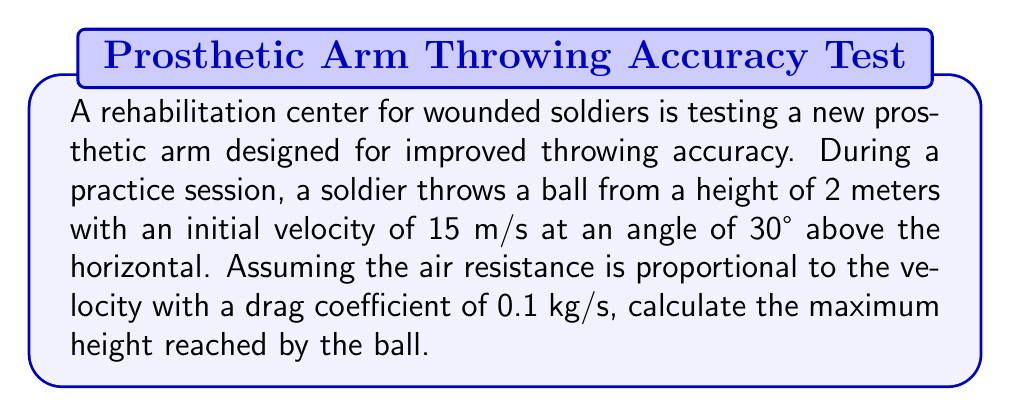Solve this math problem. To solve this problem, we need to consider the equations of motion with air resistance. Let's approach this step-by-step:

1) The equations of motion with air resistance are:

   $$\frac{dx}{dt} = v_x$$
   $$\frac{dy}{dt} = v_y$$
   $$\frac{dv_x}{dt} = -\frac{k}{m}v_x$$
   $$\frac{dv_y}{dt} = -g - \frac{k}{m}v_y$$

   Where $k$ is the drag coefficient, $m$ is the mass of the ball, and $g$ is the acceleration due to gravity.

2) The initial conditions are:
   $$x_0 = 0, y_0 = 2$$
   $$v_{x0} = v_0 \cos{\theta} = 15 \cos{30°} = 12.99 \text{ m/s}$$
   $$v_{y0} = v_0 \sin{\theta} = 15 \sin{30°} = 7.5 \text{ m/s}$$

3) To find the maximum height, we need to find when $v_y = 0$. The solution for $v_y$ is:

   $$v_y = \frac{mg}{k}(e^{-\frac{k}{m}t} - 1) + v_{y0}e^{-\frac{k}{m}t}$$

4) Setting this equal to zero and solving for $t$ gives:

   $$t = \frac{m}{k} \ln{\left(\frac{v_{y0} + \frac{mg}{k}}{\frac{mg}{k}}\right)}$$

5) Substituting this time into the equation for y:

   $$y = \frac{m}{k}\left(v_{y0} + \frac{mg}{k}\right)\left(1 - e^{-\frac{k}{m}t}\right) - \frac{mg}{k}t + y_0$$

6) Assuming the mass of the ball is 0.1 kg, and using g = 9.8 m/s^2:

   $$t = \frac{0.1}{0.1} \ln{\left(\frac{7.5 + \frac{0.1 \cdot 9.8}{0.1}}{\frac{0.1 \cdot 9.8}{0.1}}\right)} = 0.65 \text{ s}$$

7) Substituting this back into the equation for y:

   $$y_{max} = \frac{0.1}{0.1}\left(7.5 + \frac{0.1 \cdot 9.8}{0.1}\right)\left(1 - e^{-\frac{0.1}{0.1} \cdot 0.65}\right) - \frac{0.1 \cdot 9.8}{0.1} \cdot 0.65 + 2$$

8) Calculating this gives:

   $$y_{max} = 4.79 \text{ m}$$

Therefore, the maximum height reached by the ball is approximately 4.79 meters.
Answer: 4.79 m 